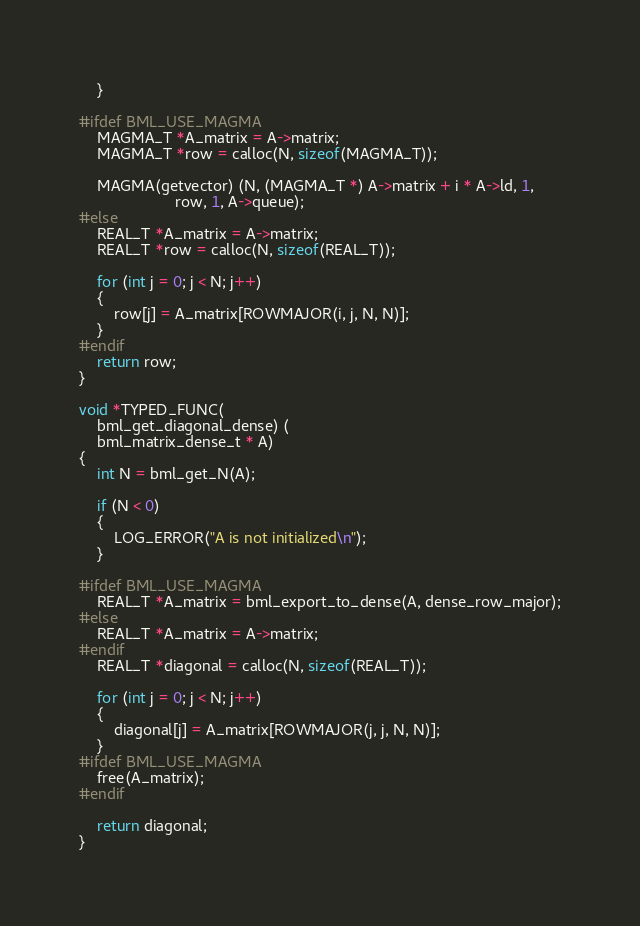<code> <loc_0><loc_0><loc_500><loc_500><_C_>    }

#ifdef BML_USE_MAGMA
    MAGMA_T *A_matrix = A->matrix;
    MAGMA_T *row = calloc(N, sizeof(MAGMA_T));

    MAGMA(getvector) (N, (MAGMA_T *) A->matrix + i * A->ld, 1,
                      row, 1, A->queue);
#else
    REAL_T *A_matrix = A->matrix;
    REAL_T *row = calloc(N, sizeof(REAL_T));

    for (int j = 0; j < N; j++)
    {
        row[j] = A_matrix[ROWMAJOR(i, j, N, N)];
    }
#endif
    return row;
}

void *TYPED_FUNC(
    bml_get_diagonal_dense) (
    bml_matrix_dense_t * A)
{
    int N = bml_get_N(A);

    if (N < 0)
    {
        LOG_ERROR("A is not initialized\n");
    }

#ifdef BML_USE_MAGMA
    REAL_T *A_matrix = bml_export_to_dense(A, dense_row_major);
#else
    REAL_T *A_matrix = A->matrix;
#endif
    REAL_T *diagonal = calloc(N, sizeof(REAL_T));

    for (int j = 0; j < N; j++)
    {
        diagonal[j] = A_matrix[ROWMAJOR(j, j, N, N)];
    }
#ifdef BML_USE_MAGMA
    free(A_matrix);
#endif

    return diagonal;
}
</code> 